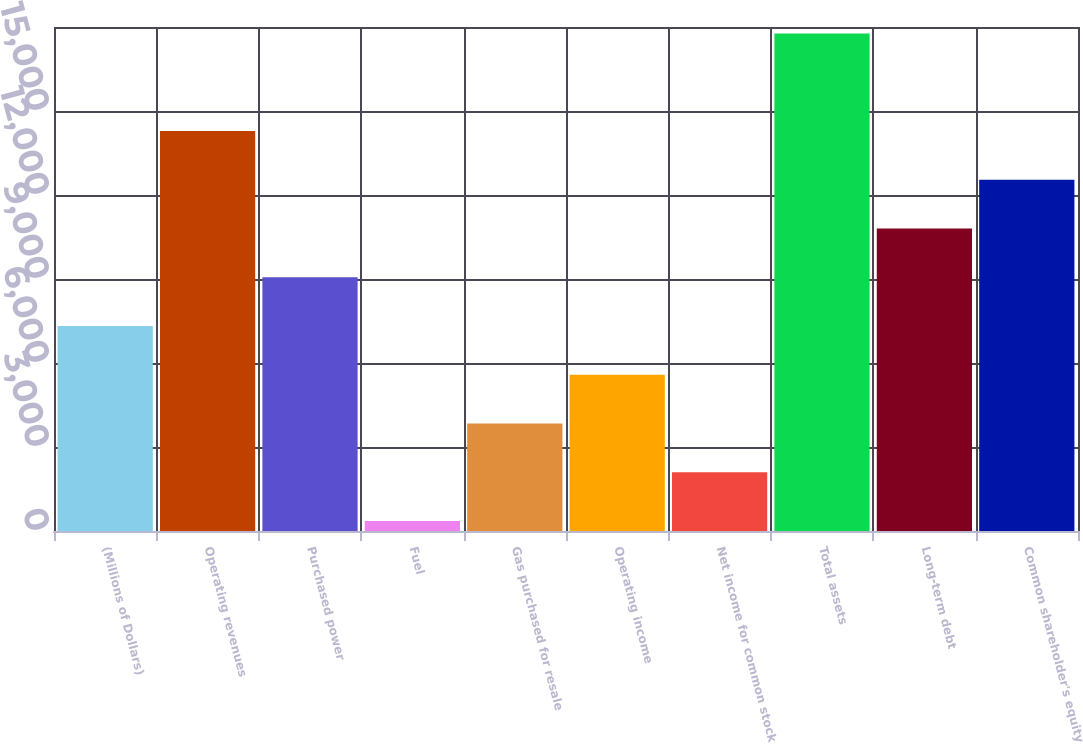<chart> <loc_0><loc_0><loc_500><loc_500><bar_chart><fcel>(Millions of Dollars)<fcel>Operating revenues<fcel>Purchased power<fcel>Fuel<fcel>Gas purchased for resale<fcel>Operating income<fcel>Net income for common stock<fcel>Total assets<fcel>Long-term debt<fcel>Common shareholder's equity<nl><fcel>7320.4<fcel>14282.8<fcel>9061<fcel>358<fcel>3839.2<fcel>5579.8<fcel>2098.6<fcel>17764<fcel>10801.6<fcel>12542.2<nl></chart> 